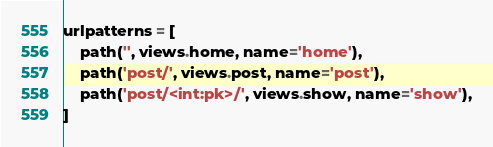Convert code to text. <code><loc_0><loc_0><loc_500><loc_500><_Python_>urlpatterns = [
    path('', views.home, name='home'),
    path('post/', views.post, name='post'),
    path('post/<int:pk>/', views.show, name='show'),
]
</code> 